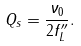<formula> <loc_0><loc_0><loc_500><loc_500>Q _ { s } = \frac { \nu _ { 0 } } { 2 f ^ { \prime \prime } _ { L } } .</formula> 